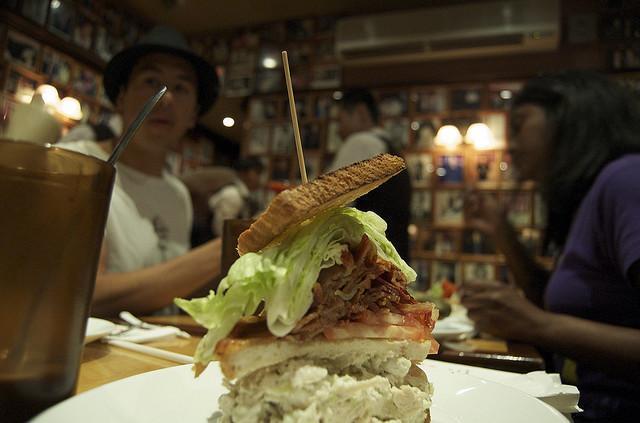How many toothpicks are in the sandwich?
Give a very brief answer. 1. How many people are there?
Give a very brief answer. 3. 